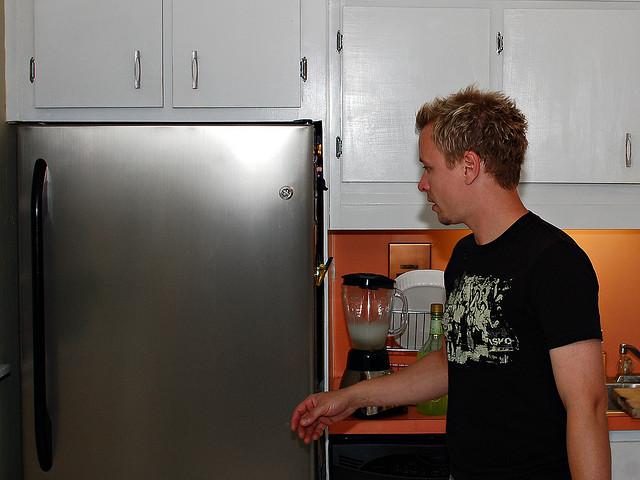What color are the cabinets?
Concise answer only. White. What is the fridge made of?
Short answer required. Stainless steel. What is underneath the man's elbow?
Give a very brief answer. Counter. Is this photo in color?
Give a very brief answer. Yes. What color is the fridge?
Answer briefly. Silver. 